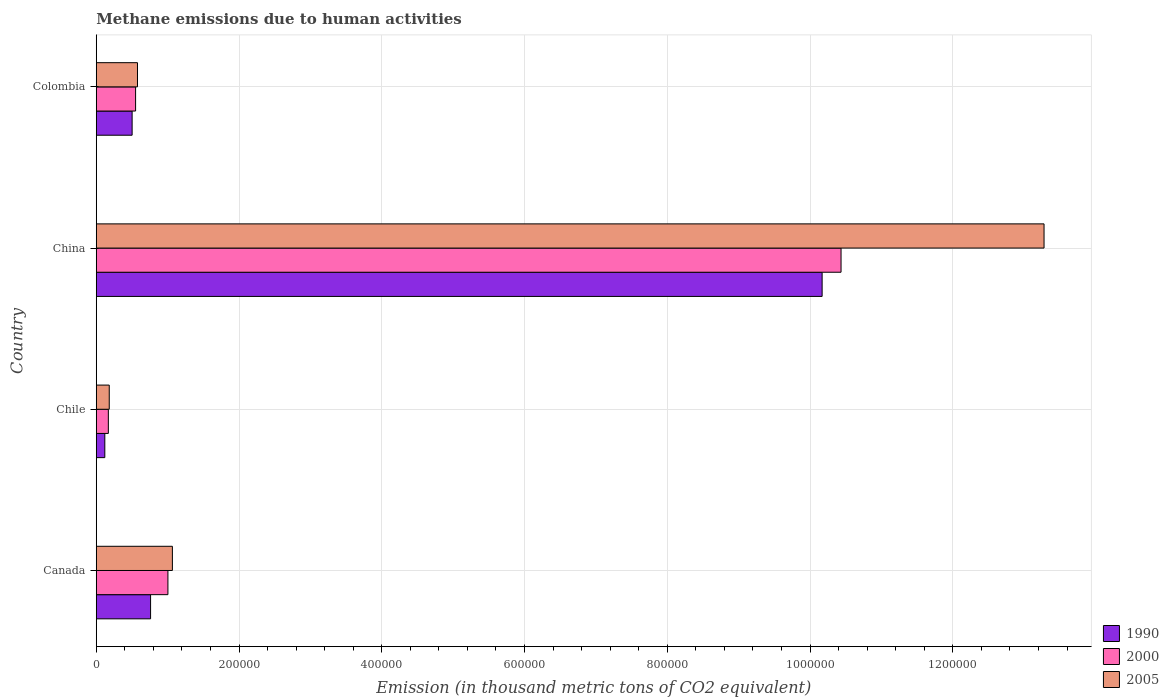How many different coloured bars are there?
Provide a succinct answer. 3. Are the number of bars per tick equal to the number of legend labels?
Offer a terse response. Yes. Are the number of bars on each tick of the Y-axis equal?
Offer a very short reply. Yes. What is the label of the 2nd group of bars from the top?
Make the answer very short. China. What is the amount of methane emitted in 2005 in Colombia?
Ensure brevity in your answer.  5.77e+04. Across all countries, what is the maximum amount of methane emitted in 2000?
Ensure brevity in your answer.  1.04e+06. Across all countries, what is the minimum amount of methane emitted in 1990?
Offer a very short reply. 1.20e+04. In which country was the amount of methane emitted in 2000 maximum?
Offer a terse response. China. In which country was the amount of methane emitted in 2005 minimum?
Provide a short and direct response. Chile. What is the total amount of methane emitted in 1990 in the graph?
Your answer should be very brief. 1.16e+06. What is the difference between the amount of methane emitted in 1990 in China and that in Colombia?
Provide a short and direct response. 9.67e+05. What is the difference between the amount of methane emitted in 1990 in Canada and the amount of methane emitted in 2005 in Colombia?
Your answer should be compact. 1.84e+04. What is the average amount of methane emitted in 2000 per country?
Give a very brief answer. 3.04e+05. What is the difference between the amount of methane emitted in 1990 and amount of methane emitted in 2000 in Colombia?
Your response must be concise. -4870.6. What is the ratio of the amount of methane emitted in 2000 in Canada to that in China?
Keep it short and to the point. 0.1. Is the amount of methane emitted in 2000 in Canada less than that in Colombia?
Give a very brief answer. No. Is the difference between the amount of methane emitted in 1990 in Chile and Colombia greater than the difference between the amount of methane emitted in 2000 in Chile and Colombia?
Ensure brevity in your answer.  No. What is the difference between the highest and the second highest amount of methane emitted in 2000?
Make the answer very short. 9.43e+05. What is the difference between the highest and the lowest amount of methane emitted in 1990?
Make the answer very short. 1.00e+06. Is the sum of the amount of methane emitted in 1990 in Chile and Colombia greater than the maximum amount of methane emitted in 2000 across all countries?
Give a very brief answer. No. Are all the bars in the graph horizontal?
Keep it short and to the point. Yes. How many countries are there in the graph?
Keep it short and to the point. 4. Are the values on the major ticks of X-axis written in scientific E-notation?
Make the answer very short. No. Does the graph contain grids?
Your answer should be very brief. Yes. What is the title of the graph?
Your answer should be very brief. Methane emissions due to human activities. Does "1966" appear as one of the legend labels in the graph?
Keep it short and to the point. No. What is the label or title of the X-axis?
Make the answer very short. Emission (in thousand metric tons of CO2 equivalent). What is the label or title of the Y-axis?
Give a very brief answer. Country. What is the Emission (in thousand metric tons of CO2 equivalent) of 1990 in Canada?
Offer a very short reply. 7.61e+04. What is the Emission (in thousand metric tons of CO2 equivalent) of 2000 in Canada?
Provide a succinct answer. 1.00e+05. What is the Emission (in thousand metric tons of CO2 equivalent) in 2005 in Canada?
Offer a terse response. 1.07e+05. What is the Emission (in thousand metric tons of CO2 equivalent) in 1990 in Chile?
Give a very brief answer. 1.20e+04. What is the Emission (in thousand metric tons of CO2 equivalent) of 2000 in Chile?
Your answer should be very brief. 1.69e+04. What is the Emission (in thousand metric tons of CO2 equivalent) in 2005 in Chile?
Offer a terse response. 1.82e+04. What is the Emission (in thousand metric tons of CO2 equivalent) of 1990 in China?
Offer a terse response. 1.02e+06. What is the Emission (in thousand metric tons of CO2 equivalent) in 2000 in China?
Your answer should be compact. 1.04e+06. What is the Emission (in thousand metric tons of CO2 equivalent) of 2005 in China?
Offer a very short reply. 1.33e+06. What is the Emission (in thousand metric tons of CO2 equivalent) in 1990 in Colombia?
Provide a succinct answer. 5.02e+04. What is the Emission (in thousand metric tons of CO2 equivalent) in 2000 in Colombia?
Provide a succinct answer. 5.51e+04. What is the Emission (in thousand metric tons of CO2 equivalent) in 2005 in Colombia?
Ensure brevity in your answer.  5.77e+04. Across all countries, what is the maximum Emission (in thousand metric tons of CO2 equivalent) of 1990?
Provide a short and direct response. 1.02e+06. Across all countries, what is the maximum Emission (in thousand metric tons of CO2 equivalent) in 2000?
Your answer should be very brief. 1.04e+06. Across all countries, what is the maximum Emission (in thousand metric tons of CO2 equivalent) in 2005?
Provide a short and direct response. 1.33e+06. Across all countries, what is the minimum Emission (in thousand metric tons of CO2 equivalent) in 1990?
Provide a succinct answer. 1.20e+04. Across all countries, what is the minimum Emission (in thousand metric tons of CO2 equivalent) of 2000?
Give a very brief answer. 1.69e+04. Across all countries, what is the minimum Emission (in thousand metric tons of CO2 equivalent) in 2005?
Ensure brevity in your answer.  1.82e+04. What is the total Emission (in thousand metric tons of CO2 equivalent) of 1990 in the graph?
Provide a succinct answer. 1.16e+06. What is the total Emission (in thousand metric tons of CO2 equivalent) of 2000 in the graph?
Your answer should be very brief. 1.22e+06. What is the total Emission (in thousand metric tons of CO2 equivalent) of 2005 in the graph?
Offer a terse response. 1.51e+06. What is the difference between the Emission (in thousand metric tons of CO2 equivalent) in 1990 in Canada and that in Chile?
Give a very brief answer. 6.41e+04. What is the difference between the Emission (in thousand metric tons of CO2 equivalent) in 2000 in Canada and that in Chile?
Provide a succinct answer. 8.35e+04. What is the difference between the Emission (in thousand metric tons of CO2 equivalent) of 2005 in Canada and that in Chile?
Give a very brief answer. 8.85e+04. What is the difference between the Emission (in thousand metric tons of CO2 equivalent) in 1990 in Canada and that in China?
Make the answer very short. -9.41e+05. What is the difference between the Emission (in thousand metric tons of CO2 equivalent) in 2000 in Canada and that in China?
Provide a short and direct response. -9.43e+05. What is the difference between the Emission (in thousand metric tons of CO2 equivalent) in 2005 in Canada and that in China?
Make the answer very short. -1.22e+06. What is the difference between the Emission (in thousand metric tons of CO2 equivalent) of 1990 in Canada and that in Colombia?
Make the answer very short. 2.59e+04. What is the difference between the Emission (in thousand metric tons of CO2 equivalent) in 2000 in Canada and that in Colombia?
Provide a short and direct response. 4.53e+04. What is the difference between the Emission (in thousand metric tons of CO2 equivalent) in 2005 in Canada and that in Colombia?
Make the answer very short. 4.89e+04. What is the difference between the Emission (in thousand metric tons of CO2 equivalent) of 1990 in Chile and that in China?
Give a very brief answer. -1.00e+06. What is the difference between the Emission (in thousand metric tons of CO2 equivalent) in 2000 in Chile and that in China?
Your answer should be compact. -1.03e+06. What is the difference between the Emission (in thousand metric tons of CO2 equivalent) of 2005 in Chile and that in China?
Your answer should be compact. -1.31e+06. What is the difference between the Emission (in thousand metric tons of CO2 equivalent) of 1990 in Chile and that in Colombia?
Ensure brevity in your answer.  -3.83e+04. What is the difference between the Emission (in thousand metric tons of CO2 equivalent) in 2000 in Chile and that in Colombia?
Offer a very short reply. -3.82e+04. What is the difference between the Emission (in thousand metric tons of CO2 equivalent) in 2005 in Chile and that in Colombia?
Your answer should be compact. -3.96e+04. What is the difference between the Emission (in thousand metric tons of CO2 equivalent) of 1990 in China and that in Colombia?
Ensure brevity in your answer.  9.67e+05. What is the difference between the Emission (in thousand metric tons of CO2 equivalent) in 2000 in China and that in Colombia?
Your response must be concise. 9.88e+05. What is the difference between the Emission (in thousand metric tons of CO2 equivalent) in 2005 in China and that in Colombia?
Offer a terse response. 1.27e+06. What is the difference between the Emission (in thousand metric tons of CO2 equivalent) in 1990 in Canada and the Emission (in thousand metric tons of CO2 equivalent) in 2000 in Chile?
Offer a very short reply. 5.92e+04. What is the difference between the Emission (in thousand metric tons of CO2 equivalent) in 1990 in Canada and the Emission (in thousand metric tons of CO2 equivalent) in 2005 in Chile?
Provide a short and direct response. 5.79e+04. What is the difference between the Emission (in thousand metric tons of CO2 equivalent) in 2000 in Canada and the Emission (in thousand metric tons of CO2 equivalent) in 2005 in Chile?
Ensure brevity in your answer.  8.22e+04. What is the difference between the Emission (in thousand metric tons of CO2 equivalent) in 1990 in Canada and the Emission (in thousand metric tons of CO2 equivalent) in 2000 in China?
Provide a succinct answer. -9.67e+05. What is the difference between the Emission (in thousand metric tons of CO2 equivalent) of 1990 in Canada and the Emission (in thousand metric tons of CO2 equivalent) of 2005 in China?
Keep it short and to the point. -1.25e+06. What is the difference between the Emission (in thousand metric tons of CO2 equivalent) in 2000 in Canada and the Emission (in thousand metric tons of CO2 equivalent) in 2005 in China?
Make the answer very short. -1.23e+06. What is the difference between the Emission (in thousand metric tons of CO2 equivalent) in 1990 in Canada and the Emission (in thousand metric tons of CO2 equivalent) in 2000 in Colombia?
Offer a very short reply. 2.10e+04. What is the difference between the Emission (in thousand metric tons of CO2 equivalent) of 1990 in Canada and the Emission (in thousand metric tons of CO2 equivalent) of 2005 in Colombia?
Keep it short and to the point. 1.84e+04. What is the difference between the Emission (in thousand metric tons of CO2 equivalent) of 2000 in Canada and the Emission (in thousand metric tons of CO2 equivalent) of 2005 in Colombia?
Your answer should be compact. 4.27e+04. What is the difference between the Emission (in thousand metric tons of CO2 equivalent) in 1990 in Chile and the Emission (in thousand metric tons of CO2 equivalent) in 2000 in China?
Provide a short and direct response. -1.03e+06. What is the difference between the Emission (in thousand metric tons of CO2 equivalent) in 1990 in Chile and the Emission (in thousand metric tons of CO2 equivalent) in 2005 in China?
Give a very brief answer. -1.32e+06. What is the difference between the Emission (in thousand metric tons of CO2 equivalent) in 2000 in Chile and the Emission (in thousand metric tons of CO2 equivalent) in 2005 in China?
Your response must be concise. -1.31e+06. What is the difference between the Emission (in thousand metric tons of CO2 equivalent) of 1990 in Chile and the Emission (in thousand metric tons of CO2 equivalent) of 2000 in Colombia?
Provide a succinct answer. -4.31e+04. What is the difference between the Emission (in thousand metric tons of CO2 equivalent) in 1990 in Chile and the Emission (in thousand metric tons of CO2 equivalent) in 2005 in Colombia?
Your answer should be very brief. -4.58e+04. What is the difference between the Emission (in thousand metric tons of CO2 equivalent) in 2000 in Chile and the Emission (in thousand metric tons of CO2 equivalent) in 2005 in Colombia?
Keep it short and to the point. -4.08e+04. What is the difference between the Emission (in thousand metric tons of CO2 equivalent) of 1990 in China and the Emission (in thousand metric tons of CO2 equivalent) of 2000 in Colombia?
Your answer should be very brief. 9.62e+05. What is the difference between the Emission (in thousand metric tons of CO2 equivalent) in 1990 in China and the Emission (in thousand metric tons of CO2 equivalent) in 2005 in Colombia?
Your answer should be very brief. 9.59e+05. What is the difference between the Emission (in thousand metric tons of CO2 equivalent) in 2000 in China and the Emission (in thousand metric tons of CO2 equivalent) in 2005 in Colombia?
Keep it short and to the point. 9.86e+05. What is the average Emission (in thousand metric tons of CO2 equivalent) of 1990 per country?
Make the answer very short. 2.89e+05. What is the average Emission (in thousand metric tons of CO2 equivalent) of 2000 per country?
Make the answer very short. 3.04e+05. What is the average Emission (in thousand metric tons of CO2 equivalent) of 2005 per country?
Offer a terse response. 3.78e+05. What is the difference between the Emission (in thousand metric tons of CO2 equivalent) of 1990 and Emission (in thousand metric tons of CO2 equivalent) of 2000 in Canada?
Your answer should be compact. -2.43e+04. What is the difference between the Emission (in thousand metric tons of CO2 equivalent) of 1990 and Emission (in thousand metric tons of CO2 equivalent) of 2005 in Canada?
Offer a very short reply. -3.06e+04. What is the difference between the Emission (in thousand metric tons of CO2 equivalent) of 2000 and Emission (in thousand metric tons of CO2 equivalent) of 2005 in Canada?
Offer a terse response. -6253.4. What is the difference between the Emission (in thousand metric tons of CO2 equivalent) in 1990 and Emission (in thousand metric tons of CO2 equivalent) in 2000 in Chile?
Make the answer very short. -4945.1. What is the difference between the Emission (in thousand metric tons of CO2 equivalent) of 1990 and Emission (in thousand metric tons of CO2 equivalent) of 2005 in Chile?
Ensure brevity in your answer.  -6211.6. What is the difference between the Emission (in thousand metric tons of CO2 equivalent) in 2000 and Emission (in thousand metric tons of CO2 equivalent) in 2005 in Chile?
Provide a short and direct response. -1266.5. What is the difference between the Emission (in thousand metric tons of CO2 equivalent) in 1990 and Emission (in thousand metric tons of CO2 equivalent) in 2000 in China?
Your answer should be compact. -2.65e+04. What is the difference between the Emission (in thousand metric tons of CO2 equivalent) in 1990 and Emission (in thousand metric tons of CO2 equivalent) in 2005 in China?
Your answer should be compact. -3.11e+05. What is the difference between the Emission (in thousand metric tons of CO2 equivalent) of 2000 and Emission (in thousand metric tons of CO2 equivalent) of 2005 in China?
Offer a terse response. -2.84e+05. What is the difference between the Emission (in thousand metric tons of CO2 equivalent) of 1990 and Emission (in thousand metric tons of CO2 equivalent) of 2000 in Colombia?
Your answer should be very brief. -4870.6. What is the difference between the Emission (in thousand metric tons of CO2 equivalent) of 1990 and Emission (in thousand metric tons of CO2 equivalent) of 2005 in Colombia?
Provide a succinct answer. -7500.3. What is the difference between the Emission (in thousand metric tons of CO2 equivalent) in 2000 and Emission (in thousand metric tons of CO2 equivalent) in 2005 in Colombia?
Give a very brief answer. -2629.7. What is the ratio of the Emission (in thousand metric tons of CO2 equivalent) in 1990 in Canada to that in Chile?
Provide a short and direct response. 6.35. What is the ratio of the Emission (in thousand metric tons of CO2 equivalent) of 2000 in Canada to that in Chile?
Ensure brevity in your answer.  5.93. What is the ratio of the Emission (in thousand metric tons of CO2 equivalent) in 2005 in Canada to that in Chile?
Offer a very short reply. 5.86. What is the ratio of the Emission (in thousand metric tons of CO2 equivalent) of 1990 in Canada to that in China?
Keep it short and to the point. 0.07. What is the ratio of the Emission (in thousand metric tons of CO2 equivalent) of 2000 in Canada to that in China?
Provide a short and direct response. 0.1. What is the ratio of the Emission (in thousand metric tons of CO2 equivalent) of 2005 in Canada to that in China?
Your response must be concise. 0.08. What is the ratio of the Emission (in thousand metric tons of CO2 equivalent) in 1990 in Canada to that in Colombia?
Provide a short and direct response. 1.51. What is the ratio of the Emission (in thousand metric tons of CO2 equivalent) of 2000 in Canada to that in Colombia?
Your response must be concise. 1.82. What is the ratio of the Emission (in thousand metric tons of CO2 equivalent) of 2005 in Canada to that in Colombia?
Make the answer very short. 1.85. What is the ratio of the Emission (in thousand metric tons of CO2 equivalent) in 1990 in Chile to that in China?
Give a very brief answer. 0.01. What is the ratio of the Emission (in thousand metric tons of CO2 equivalent) of 2000 in Chile to that in China?
Provide a short and direct response. 0.02. What is the ratio of the Emission (in thousand metric tons of CO2 equivalent) of 2005 in Chile to that in China?
Ensure brevity in your answer.  0.01. What is the ratio of the Emission (in thousand metric tons of CO2 equivalent) of 1990 in Chile to that in Colombia?
Offer a terse response. 0.24. What is the ratio of the Emission (in thousand metric tons of CO2 equivalent) in 2000 in Chile to that in Colombia?
Give a very brief answer. 0.31. What is the ratio of the Emission (in thousand metric tons of CO2 equivalent) of 2005 in Chile to that in Colombia?
Ensure brevity in your answer.  0.32. What is the ratio of the Emission (in thousand metric tons of CO2 equivalent) of 1990 in China to that in Colombia?
Offer a terse response. 20.24. What is the ratio of the Emission (in thousand metric tons of CO2 equivalent) of 2000 in China to that in Colombia?
Provide a short and direct response. 18.93. What is the ratio of the Emission (in thousand metric tons of CO2 equivalent) in 2005 in China to that in Colombia?
Ensure brevity in your answer.  23. What is the difference between the highest and the second highest Emission (in thousand metric tons of CO2 equivalent) of 1990?
Ensure brevity in your answer.  9.41e+05. What is the difference between the highest and the second highest Emission (in thousand metric tons of CO2 equivalent) of 2000?
Offer a very short reply. 9.43e+05. What is the difference between the highest and the second highest Emission (in thousand metric tons of CO2 equivalent) in 2005?
Offer a very short reply. 1.22e+06. What is the difference between the highest and the lowest Emission (in thousand metric tons of CO2 equivalent) in 1990?
Ensure brevity in your answer.  1.00e+06. What is the difference between the highest and the lowest Emission (in thousand metric tons of CO2 equivalent) of 2000?
Provide a succinct answer. 1.03e+06. What is the difference between the highest and the lowest Emission (in thousand metric tons of CO2 equivalent) of 2005?
Your answer should be compact. 1.31e+06. 